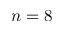Convert formula to latex. <formula><loc_0><loc_0><loc_500><loc_500>n = 8</formula> 